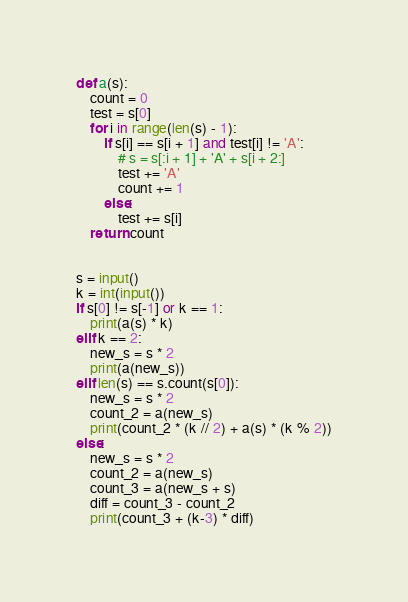Convert code to text. <code><loc_0><loc_0><loc_500><loc_500><_Python_>def a(s):
    count = 0
    test = s[0]
    for i in range(len(s) - 1):
        if s[i] == s[i + 1] and test[i] != 'A':
            # s = s[:i + 1] + 'A' + s[i + 2:]
            test += 'A'
            count += 1
        else:
            test += s[i]
    return count


s = input()
k = int(input())
if s[0] != s[-1] or k == 1:
    print(a(s) * k)
elif k == 2:
    new_s = s * 2
    print(a(new_s))
elif len(s) == s.count(s[0]):
    new_s = s * 2
    count_2 = a(new_s)
    print(count_2 * (k // 2) + a(s) * (k % 2))
else:
    new_s = s * 2
    count_2 = a(new_s)
    count_3 = a(new_s + s)
    diff = count_3 - count_2
    print(count_3 + (k-3) * diff)
</code> 